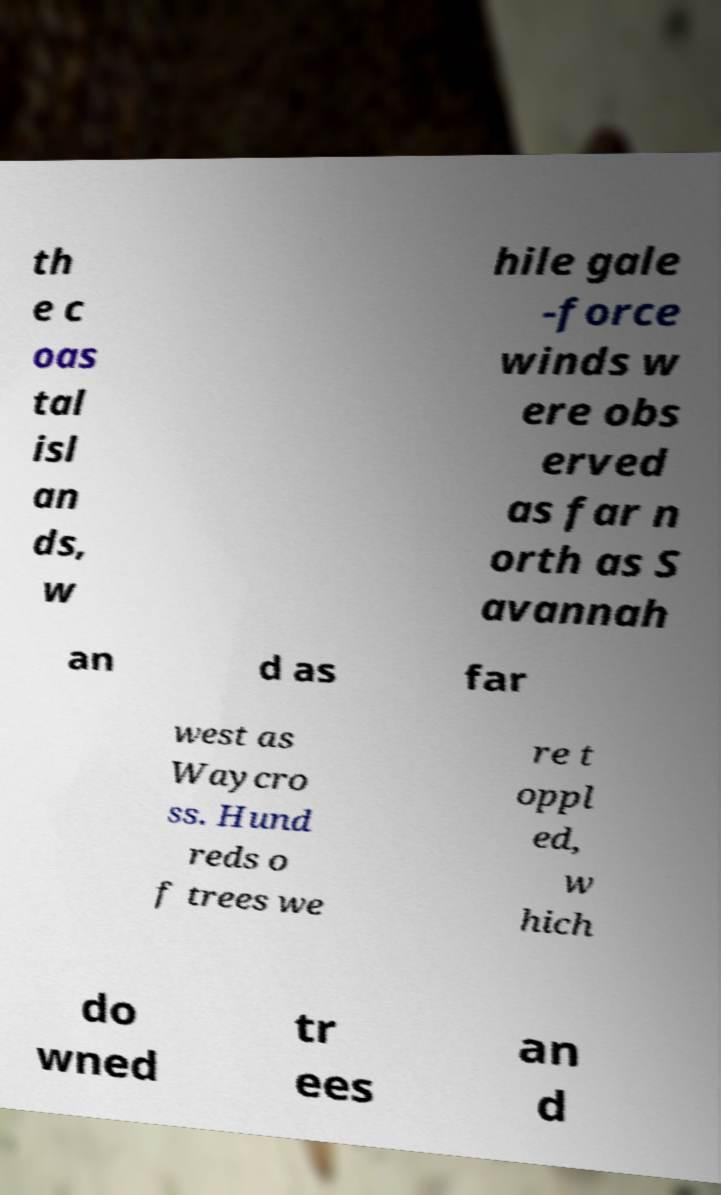Could you extract and type out the text from this image? th e c oas tal isl an ds, w hile gale -force winds w ere obs erved as far n orth as S avannah an d as far west as Waycro ss. Hund reds o f trees we re t oppl ed, w hich do wned tr ees an d 